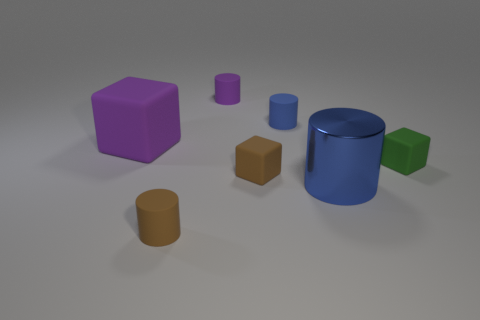Subtract all purple rubber cubes. How many cubes are left? 2 Subtract all red cubes. How many blue cylinders are left? 2 Subtract all purple cylinders. How many cylinders are left? 3 Add 3 big red rubber blocks. How many objects exist? 10 Subtract all cubes. How many objects are left? 4 Subtract all green cylinders. Subtract all purple cubes. How many cylinders are left? 4 Subtract 0 red cylinders. How many objects are left? 7 Subtract all small blue cylinders. Subtract all blue shiny things. How many objects are left? 5 Add 3 small brown cylinders. How many small brown cylinders are left? 4 Add 7 purple objects. How many purple objects exist? 9 